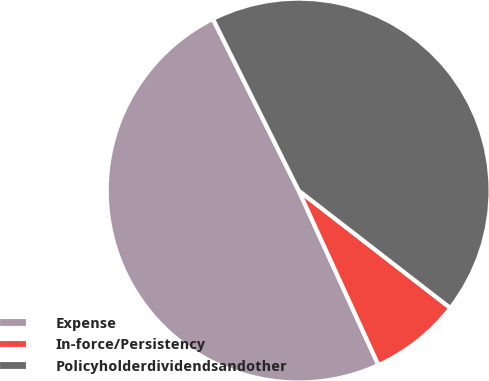Convert chart. <chart><loc_0><loc_0><loc_500><loc_500><pie_chart><fcel>Expense<fcel>In-force/Persistency<fcel>Policyholderdividendsandother<nl><fcel>49.45%<fcel>7.69%<fcel>42.86%<nl></chart> 